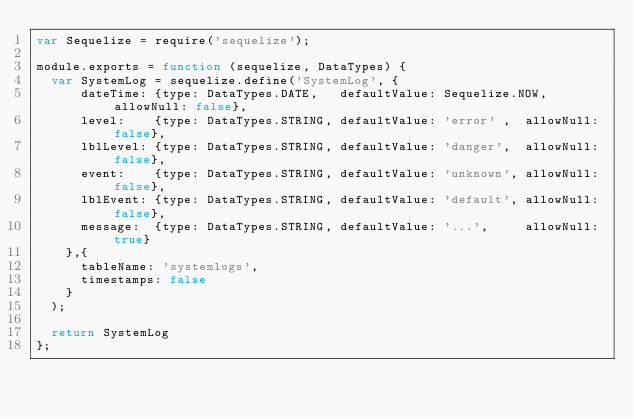Convert code to text. <code><loc_0><loc_0><loc_500><loc_500><_JavaScript_>var Sequelize = require('sequelize');

module.exports = function (sequelize, DataTypes) {
	var SystemLog = sequelize.define('SystemLog', {
			dateTime: {type: DataTypes.DATE,   defaultValue: Sequelize.NOW, allowNull: false},
			level:    {type: DataTypes.STRING, defaultValue: 'error' ,  allowNull: false},
			lblLevel: {type: DataTypes.STRING, defaultValue: 'danger',  allowNull: false},
			event:    {type: DataTypes.STRING, defaultValue: 'unknown', allowNull: false},
			lblEvent: {type: DataTypes.STRING, defaultValue: 'default', allowNull: false},
			message:  {type: DataTypes.STRING, defaultValue: '...',     allowNull: true}
		},{
			tableName: 'systemlogs',
			timestamps: false
		}
	);

	return SystemLog
};
</code> 